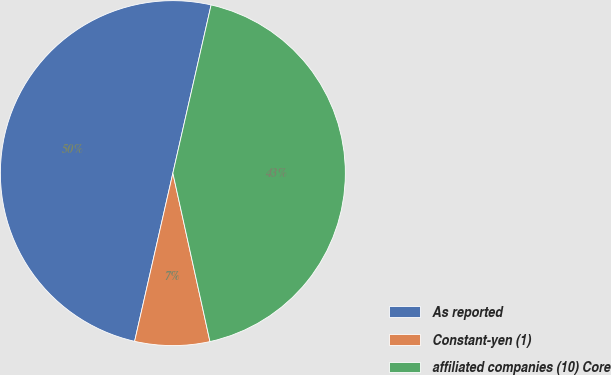<chart> <loc_0><loc_0><loc_500><loc_500><pie_chart><fcel>As reported<fcel>Constant-yen (1)<fcel>affiliated companies (10) Core<nl><fcel>50.0%<fcel>7.01%<fcel>42.99%<nl></chart> 